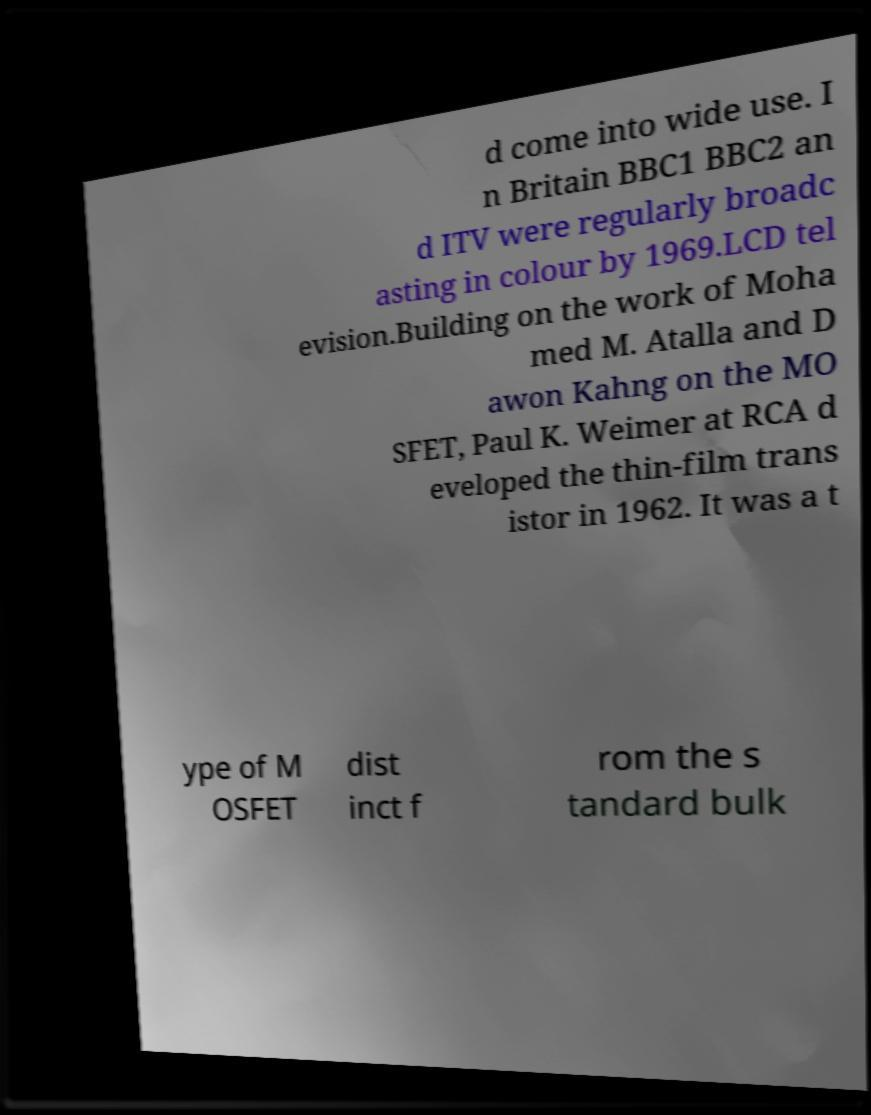Could you extract and type out the text from this image? d come into wide use. I n Britain BBC1 BBC2 an d ITV were regularly broadc asting in colour by 1969.LCD tel evision.Building on the work of Moha med M. Atalla and D awon Kahng on the MO SFET, Paul K. Weimer at RCA d eveloped the thin-film trans istor in 1962. It was a t ype of M OSFET dist inct f rom the s tandard bulk 